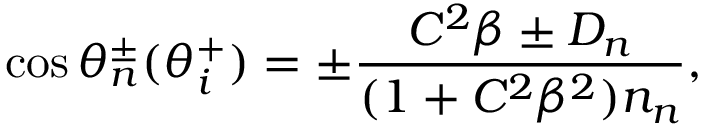Convert formula to latex. <formula><loc_0><loc_0><loc_500><loc_500>\cos \theta _ { n } ^ { \pm } ( \theta _ { i } ^ { + } ) = \pm \frac { C ^ { 2 } \beta \pm D _ { n } } { ( 1 + C ^ { 2 } \beta ^ { 2 } ) n _ { n } } ,</formula> 